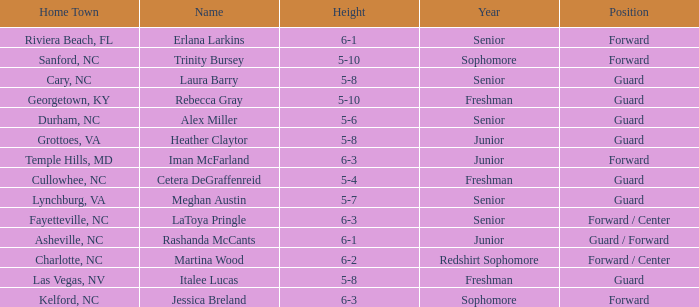What is the height of the player from Las Vegas, NV? 5-8. 